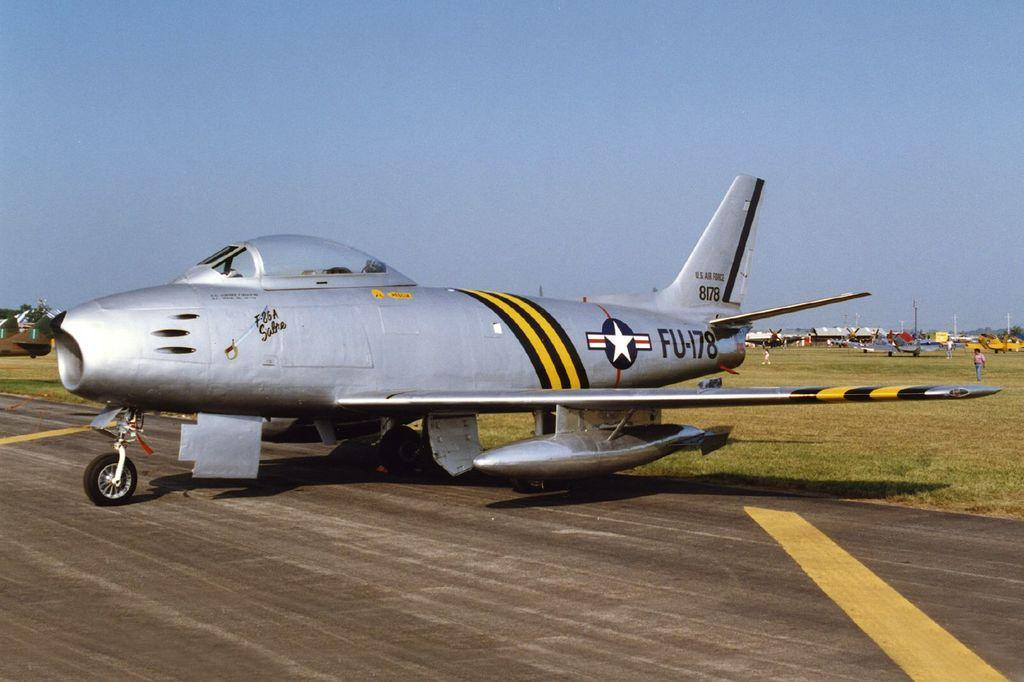Provide a one-sentence caption for the provided image. An FU-178 jet is resting near the edge of a runway. 